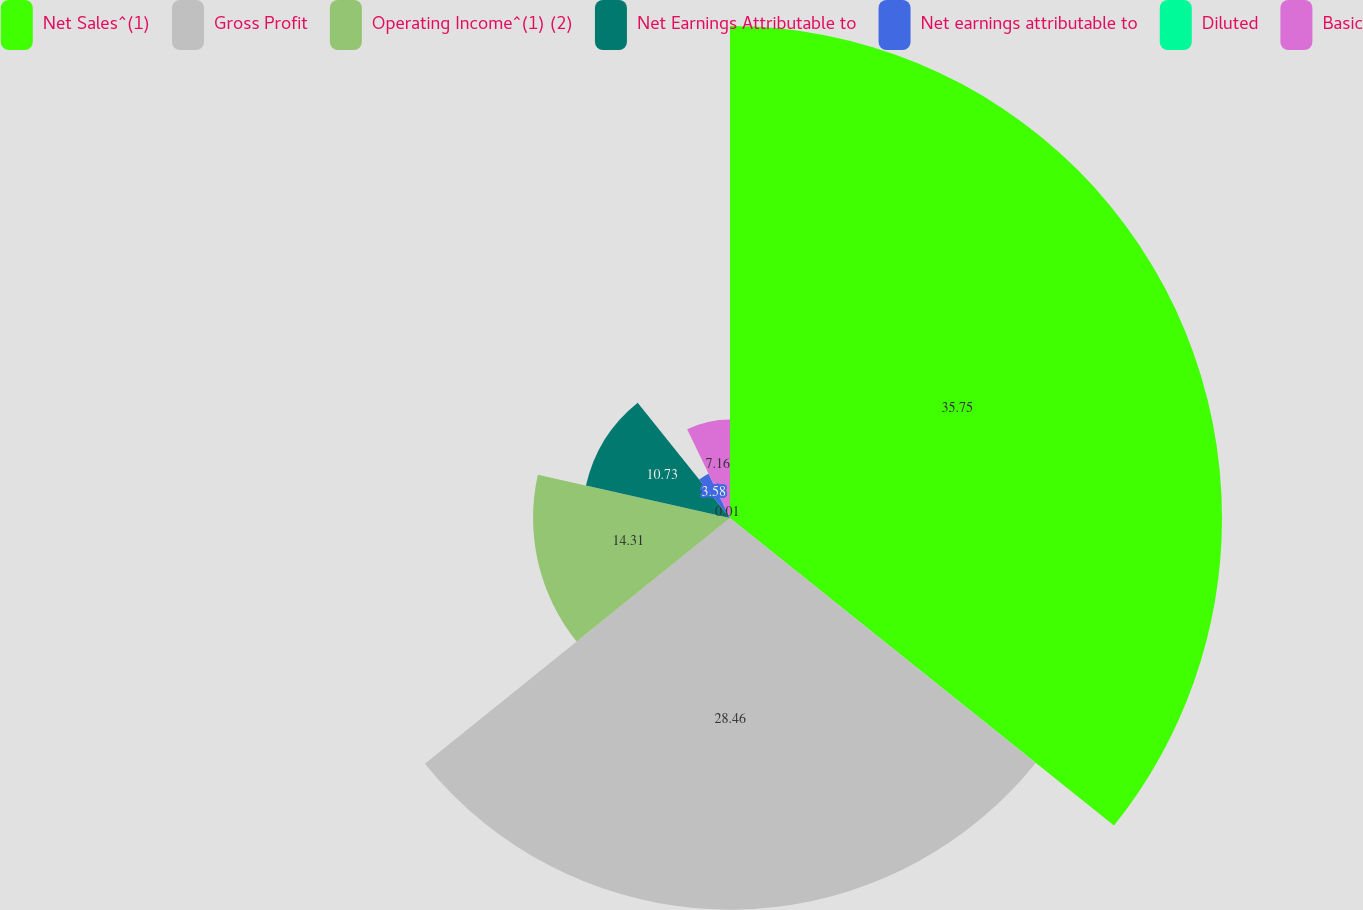Convert chart to OTSL. <chart><loc_0><loc_0><loc_500><loc_500><pie_chart><fcel>Net Sales^(1)<fcel>Gross Profit<fcel>Operating Income^(1) (2)<fcel>Net Earnings Attributable to<fcel>Net earnings attributable to<fcel>Diluted<fcel>Basic<nl><fcel>35.75%<fcel>28.46%<fcel>14.31%<fcel>10.73%<fcel>3.58%<fcel>0.01%<fcel>7.16%<nl></chart> 